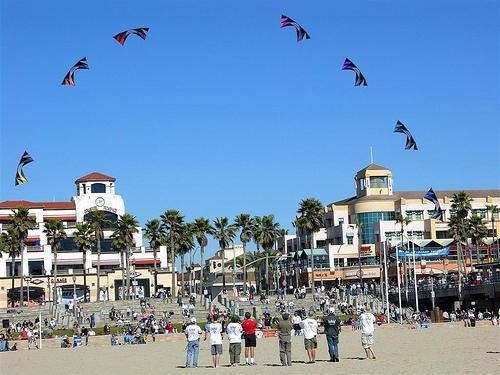The items the people are staring at are likely made of what? Please explain your reasoning. cloth. The other options are too heave and would not work for a kite. 